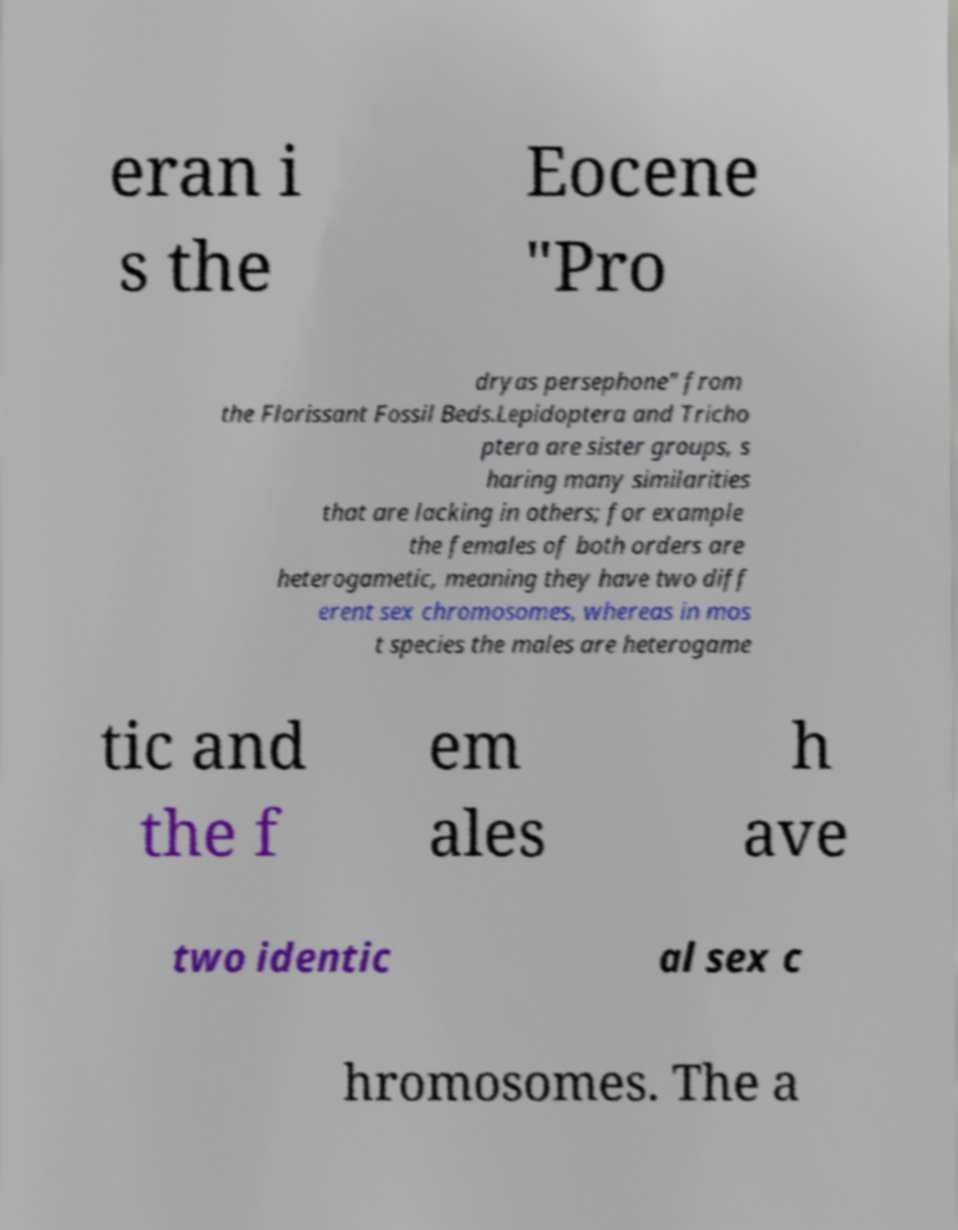Can you read and provide the text displayed in the image?This photo seems to have some interesting text. Can you extract and type it out for me? eran i s the Eocene "Pro dryas persephone" from the Florissant Fossil Beds.Lepidoptera and Tricho ptera are sister groups, s haring many similarities that are lacking in others; for example the females of both orders are heterogametic, meaning they have two diff erent sex chromosomes, whereas in mos t species the males are heterogame tic and the f em ales h ave two identic al sex c hromosomes. The a 